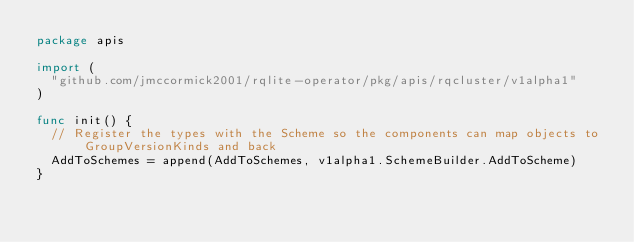<code> <loc_0><loc_0><loc_500><loc_500><_Go_>package apis

import (
	"github.com/jmccormick2001/rqlite-operator/pkg/apis/rqcluster/v1alpha1"
)

func init() {
	// Register the types with the Scheme so the components can map objects to GroupVersionKinds and back
	AddToSchemes = append(AddToSchemes, v1alpha1.SchemeBuilder.AddToScheme)
}
</code> 